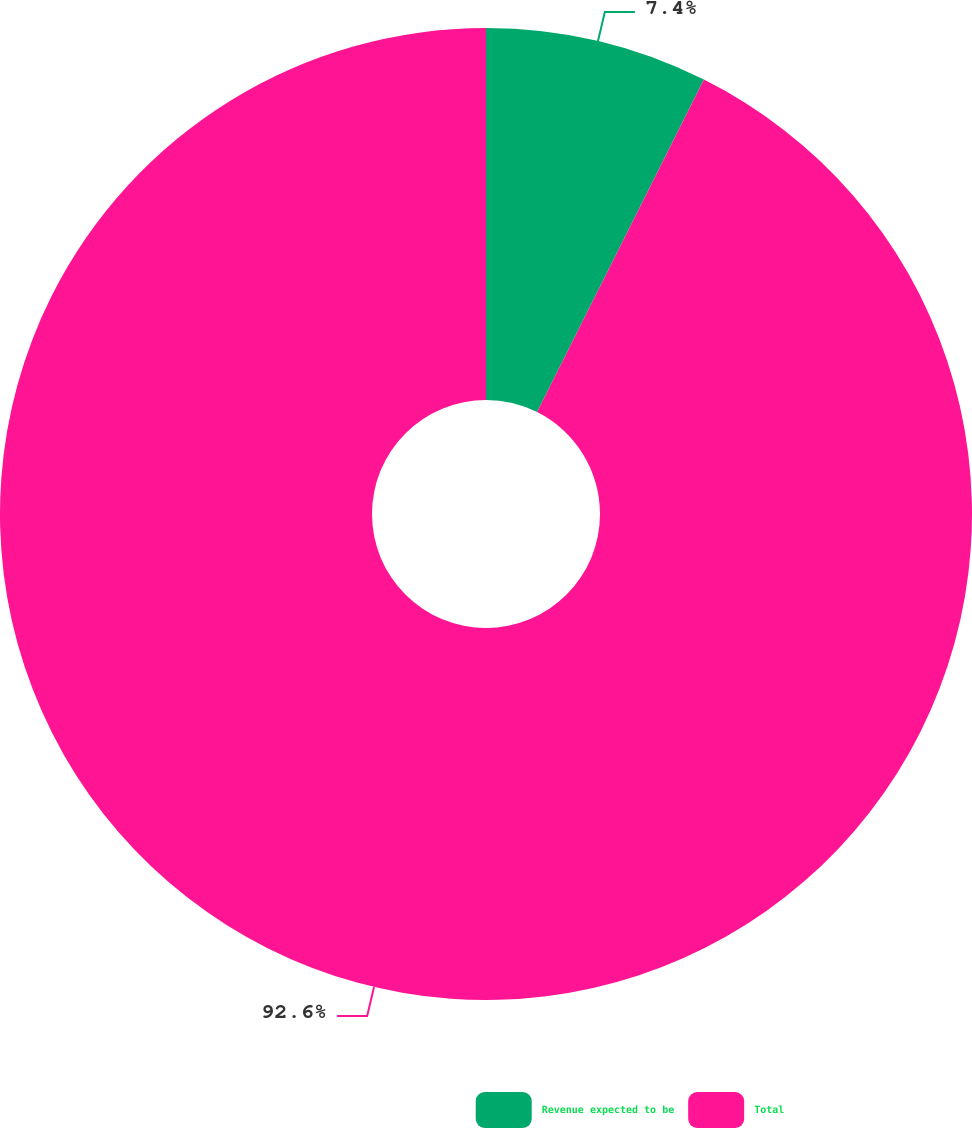Convert chart to OTSL. <chart><loc_0><loc_0><loc_500><loc_500><pie_chart><fcel>Revenue expected to be<fcel>Total<nl><fcel>7.4%<fcel>92.6%<nl></chart> 